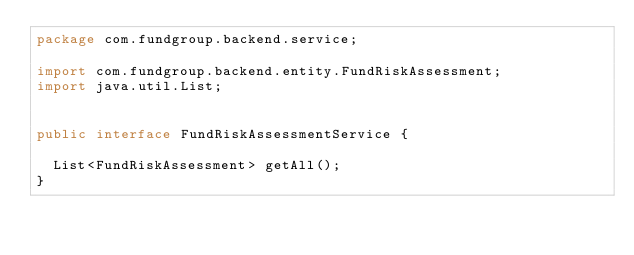<code> <loc_0><loc_0><loc_500><loc_500><_Java_>package com.fundgroup.backend.service;

import com.fundgroup.backend.entity.FundRiskAssessment;
import java.util.List;


public interface FundRiskAssessmentService {

  List<FundRiskAssessment> getAll();
}
</code> 